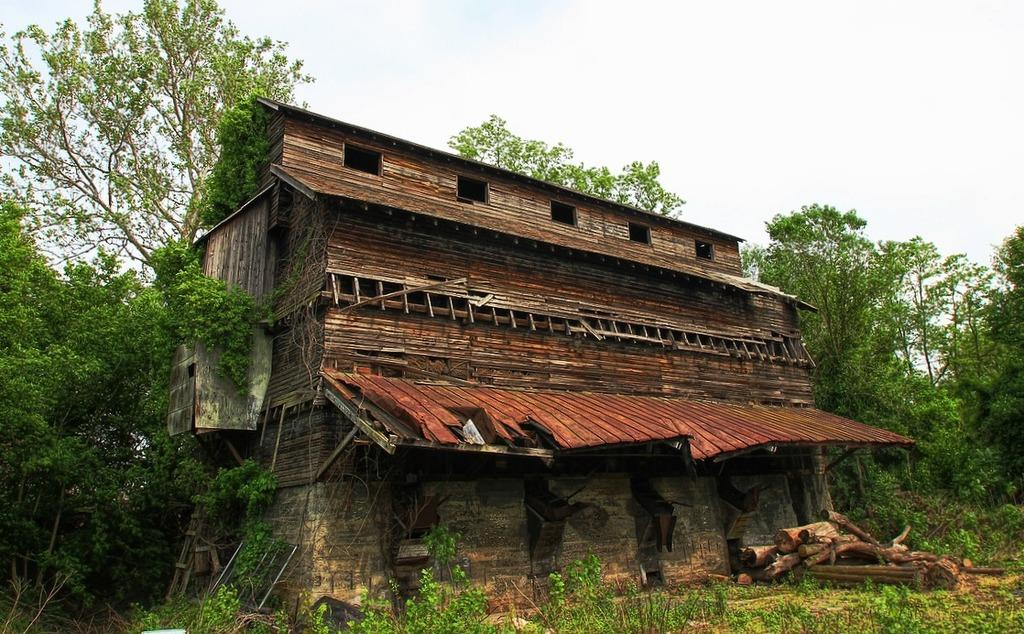What type of building is in the center of the image? There is a wooden building in the center of the image. What surrounds the wooden building? Trees are present around the wooden building. What objects are visible at the bottom of the image? Wooden blocks and plants are visible at the bottom of the image. What type of vegetation is present at the bottom of the image? Grass is visible at the bottom of the image. What can be seen in the background of the image? A: The sky is visible in the background of the image. Who is the representative sleeping in the image? There is no representative or sleeping person present in the image. What rule applies to the wooden blocks in the image? There is no rule mentioned or implied for the wooden blocks in the image. 